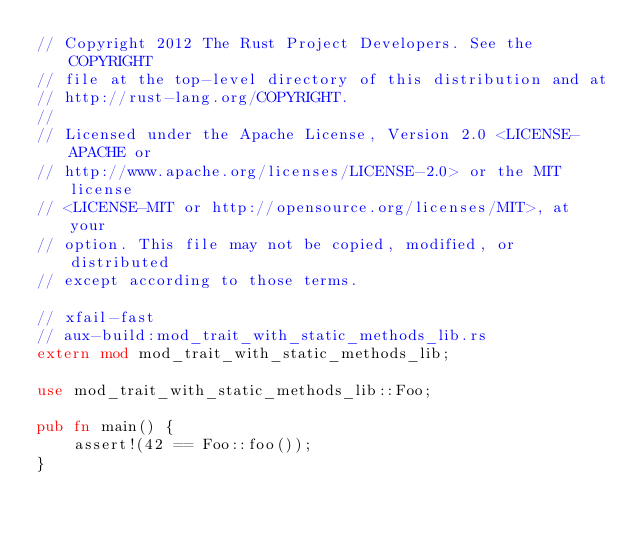Convert code to text. <code><loc_0><loc_0><loc_500><loc_500><_Rust_>// Copyright 2012 The Rust Project Developers. See the COPYRIGHT
// file at the top-level directory of this distribution and at
// http://rust-lang.org/COPYRIGHT.
//
// Licensed under the Apache License, Version 2.0 <LICENSE-APACHE or
// http://www.apache.org/licenses/LICENSE-2.0> or the MIT license
// <LICENSE-MIT or http://opensource.org/licenses/MIT>, at your
// option. This file may not be copied, modified, or distributed
// except according to those terms.

// xfail-fast
// aux-build:mod_trait_with_static_methods_lib.rs
extern mod mod_trait_with_static_methods_lib;

use mod_trait_with_static_methods_lib::Foo;

pub fn main() {
    assert!(42 == Foo::foo());
}
</code> 